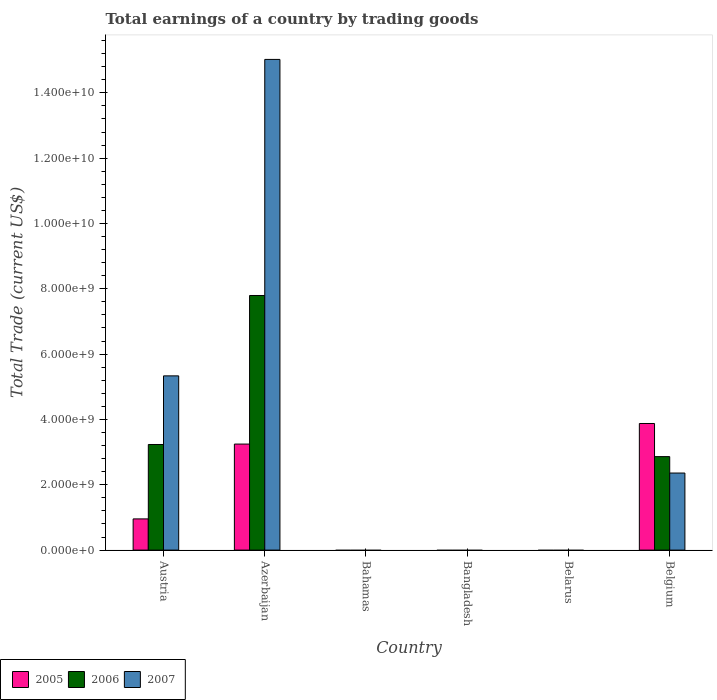What is the total earnings in 2006 in Austria?
Make the answer very short. 3.23e+09. Across all countries, what is the maximum total earnings in 2007?
Make the answer very short. 1.50e+1. Across all countries, what is the minimum total earnings in 2006?
Offer a very short reply. 0. In which country was the total earnings in 2006 maximum?
Provide a short and direct response. Azerbaijan. What is the total total earnings in 2006 in the graph?
Provide a succinct answer. 1.39e+1. What is the difference between the total earnings in 2005 in Austria and that in Belgium?
Offer a terse response. -2.92e+09. What is the difference between the total earnings in 2006 in Bahamas and the total earnings in 2005 in Belgium?
Your response must be concise. -3.88e+09. What is the average total earnings in 2005 per country?
Ensure brevity in your answer.  1.35e+09. What is the difference between the total earnings of/in 2007 and total earnings of/in 2006 in Azerbaijan?
Give a very brief answer. 7.23e+09. What is the ratio of the total earnings in 2006 in Azerbaijan to that in Belgium?
Keep it short and to the point. 2.72. Is the difference between the total earnings in 2007 in Austria and Belgium greater than the difference between the total earnings in 2006 in Austria and Belgium?
Your response must be concise. Yes. What is the difference between the highest and the second highest total earnings in 2006?
Offer a terse response. 4.56e+09. What is the difference between the highest and the lowest total earnings in 2006?
Your response must be concise. 7.80e+09. Is the sum of the total earnings in 2007 in Austria and Belgium greater than the maximum total earnings in 2005 across all countries?
Offer a terse response. Yes. How many bars are there?
Your answer should be compact. 9. Are all the bars in the graph horizontal?
Give a very brief answer. No. How many countries are there in the graph?
Provide a short and direct response. 6. Are the values on the major ticks of Y-axis written in scientific E-notation?
Make the answer very short. Yes. Does the graph contain any zero values?
Your response must be concise. Yes. Where does the legend appear in the graph?
Keep it short and to the point. Bottom left. How are the legend labels stacked?
Offer a very short reply. Horizontal. What is the title of the graph?
Give a very brief answer. Total earnings of a country by trading goods. Does "2003" appear as one of the legend labels in the graph?
Keep it short and to the point. No. What is the label or title of the Y-axis?
Provide a short and direct response. Total Trade (current US$). What is the Total Trade (current US$) in 2005 in Austria?
Your response must be concise. 9.55e+08. What is the Total Trade (current US$) in 2006 in Austria?
Your response must be concise. 3.23e+09. What is the Total Trade (current US$) of 2007 in Austria?
Your answer should be very brief. 5.33e+09. What is the Total Trade (current US$) in 2005 in Azerbaijan?
Provide a short and direct response. 3.25e+09. What is the Total Trade (current US$) in 2006 in Azerbaijan?
Keep it short and to the point. 7.80e+09. What is the Total Trade (current US$) in 2007 in Azerbaijan?
Make the answer very short. 1.50e+1. What is the Total Trade (current US$) in 2007 in Bahamas?
Your answer should be very brief. 0. What is the Total Trade (current US$) in 2005 in Bangladesh?
Your answer should be compact. 0. What is the Total Trade (current US$) of 2006 in Bangladesh?
Your answer should be very brief. 0. What is the Total Trade (current US$) of 2005 in Belgium?
Keep it short and to the point. 3.88e+09. What is the Total Trade (current US$) in 2006 in Belgium?
Ensure brevity in your answer.  2.86e+09. What is the Total Trade (current US$) in 2007 in Belgium?
Provide a succinct answer. 2.36e+09. Across all countries, what is the maximum Total Trade (current US$) in 2005?
Offer a very short reply. 3.88e+09. Across all countries, what is the maximum Total Trade (current US$) of 2006?
Provide a short and direct response. 7.80e+09. Across all countries, what is the maximum Total Trade (current US$) in 2007?
Your response must be concise. 1.50e+1. Across all countries, what is the minimum Total Trade (current US$) in 2005?
Keep it short and to the point. 0. Across all countries, what is the minimum Total Trade (current US$) in 2006?
Your response must be concise. 0. What is the total Total Trade (current US$) in 2005 in the graph?
Your response must be concise. 8.08e+09. What is the total Total Trade (current US$) in 2006 in the graph?
Make the answer very short. 1.39e+1. What is the total Total Trade (current US$) of 2007 in the graph?
Provide a succinct answer. 2.27e+1. What is the difference between the Total Trade (current US$) in 2005 in Austria and that in Azerbaijan?
Provide a succinct answer. -2.29e+09. What is the difference between the Total Trade (current US$) in 2006 in Austria and that in Azerbaijan?
Give a very brief answer. -4.56e+09. What is the difference between the Total Trade (current US$) in 2007 in Austria and that in Azerbaijan?
Ensure brevity in your answer.  -9.69e+09. What is the difference between the Total Trade (current US$) of 2005 in Austria and that in Belgium?
Ensure brevity in your answer.  -2.92e+09. What is the difference between the Total Trade (current US$) in 2006 in Austria and that in Belgium?
Keep it short and to the point. 3.71e+08. What is the difference between the Total Trade (current US$) in 2007 in Austria and that in Belgium?
Offer a very short reply. 2.97e+09. What is the difference between the Total Trade (current US$) of 2005 in Azerbaijan and that in Belgium?
Your answer should be compact. -6.30e+08. What is the difference between the Total Trade (current US$) of 2006 in Azerbaijan and that in Belgium?
Make the answer very short. 4.93e+09. What is the difference between the Total Trade (current US$) of 2007 in Azerbaijan and that in Belgium?
Keep it short and to the point. 1.27e+1. What is the difference between the Total Trade (current US$) in 2005 in Austria and the Total Trade (current US$) in 2006 in Azerbaijan?
Your answer should be compact. -6.84e+09. What is the difference between the Total Trade (current US$) of 2005 in Austria and the Total Trade (current US$) of 2007 in Azerbaijan?
Make the answer very short. -1.41e+1. What is the difference between the Total Trade (current US$) of 2006 in Austria and the Total Trade (current US$) of 2007 in Azerbaijan?
Ensure brevity in your answer.  -1.18e+1. What is the difference between the Total Trade (current US$) of 2005 in Austria and the Total Trade (current US$) of 2006 in Belgium?
Keep it short and to the point. -1.91e+09. What is the difference between the Total Trade (current US$) in 2005 in Austria and the Total Trade (current US$) in 2007 in Belgium?
Keep it short and to the point. -1.40e+09. What is the difference between the Total Trade (current US$) of 2006 in Austria and the Total Trade (current US$) of 2007 in Belgium?
Provide a succinct answer. 8.74e+08. What is the difference between the Total Trade (current US$) of 2005 in Azerbaijan and the Total Trade (current US$) of 2006 in Belgium?
Give a very brief answer. 3.84e+08. What is the difference between the Total Trade (current US$) of 2005 in Azerbaijan and the Total Trade (current US$) of 2007 in Belgium?
Make the answer very short. 8.87e+08. What is the difference between the Total Trade (current US$) of 2006 in Azerbaijan and the Total Trade (current US$) of 2007 in Belgium?
Your response must be concise. 5.44e+09. What is the average Total Trade (current US$) of 2005 per country?
Make the answer very short. 1.35e+09. What is the average Total Trade (current US$) of 2006 per country?
Offer a terse response. 2.32e+09. What is the average Total Trade (current US$) in 2007 per country?
Keep it short and to the point. 3.79e+09. What is the difference between the Total Trade (current US$) of 2005 and Total Trade (current US$) of 2006 in Austria?
Your answer should be very brief. -2.28e+09. What is the difference between the Total Trade (current US$) of 2005 and Total Trade (current US$) of 2007 in Austria?
Offer a very short reply. -4.38e+09. What is the difference between the Total Trade (current US$) of 2006 and Total Trade (current US$) of 2007 in Austria?
Your answer should be very brief. -2.10e+09. What is the difference between the Total Trade (current US$) of 2005 and Total Trade (current US$) of 2006 in Azerbaijan?
Your response must be concise. -4.55e+09. What is the difference between the Total Trade (current US$) of 2005 and Total Trade (current US$) of 2007 in Azerbaijan?
Offer a terse response. -1.18e+1. What is the difference between the Total Trade (current US$) in 2006 and Total Trade (current US$) in 2007 in Azerbaijan?
Keep it short and to the point. -7.23e+09. What is the difference between the Total Trade (current US$) of 2005 and Total Trade (current US$) of 2006 in Belgium?
Provide a succinct answer. 1.01e+09. What is the difference between the Total Trade (current US$) in 2005 and Total Trade (current US$) in 2007 in Belgium?
Your response must be concise. 1.52e+09. What is the difference between the Total Trade (current US$) in 2006 and Total Trade (current US$) in 2007 in Belgium?
Give a very brief answer. 5.03e+08. What is the ratio of the Total Trade (current US$) of 2005 in Austria to that in Azerbaijan?
Give a very brief answer. 0.29. What is the ratio of the Total Trade (current US$) of 2006 in Austria to that in Azerbaijan?
Provide a short and direct response. 0.41. What is the ratio of the Total Trade (current US$) of 2007 in Austria to that in Azerbaijan?
Give a very brief answer. 0.36. What is the ratio of the Total Trade (current US$) of 2005 in Austria to that in Belgium?
Provide a short and direct response. 0.25. What is the ratio of the Total Trade (current US$) in 2006 in Austria to that in Belgium?
Offer a terse response. 1.13. What is the ratio of the Total Trade (current US$) in 2007 in Austria to that in Belgium?
Give a very brief answer. 2.26. What is the ratio of the Total Trade (current US$) of 2005 in Azerbaijan to that in Belgium?
Provide a succinct answer. 0.84. What is the ratio of the Total Trade (current US$) in 2006 in Azerbaijan to that in Belgium?
Give a very brief answer. 2.72. What is the ratio of the Total Trade (current US$) in 2007 in Azerbaijan to that in Belgium?
Provide a succinct answer. 6.37. What is the difference between the highest and the second highest Total Trade (current US$) of 2005?
Provide a short and direct response. 6.30e+08. What is the difference between the highest and the second highest Total Trade (current US$) in 2006?
Give a very brief answer. 4.56e+09. What is the difference between the highest and the second highest Total Trade (current US$) of 2007?
Provide a short and direct response. 9.69e+09. What is the difference between the highest and the lowest Total Trade (current US$) in 2005?
Keep it short and to the point. 3.88e+09. What is the difference between the highest and the lowest Total Trade (current US$) in 2006?
Make the answer very short. 7.80e+09. What is the difference between the highest and the lowest Total Trade (current US$) in 2007?
Your answer should be very brief. 1.50e+1. 